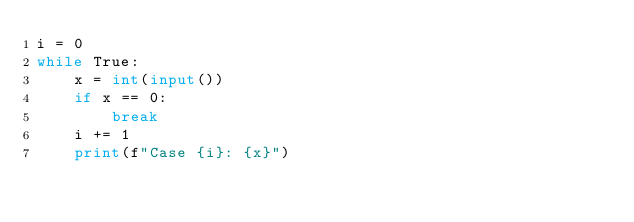<code> <loc_0><loc_0><loc_500><loc_500><_Python_>i = 0
while True:
    x = int(input())
    if x == 0:
        break
    i += 1
    print(f"Case {i}: {x}")
</code> 